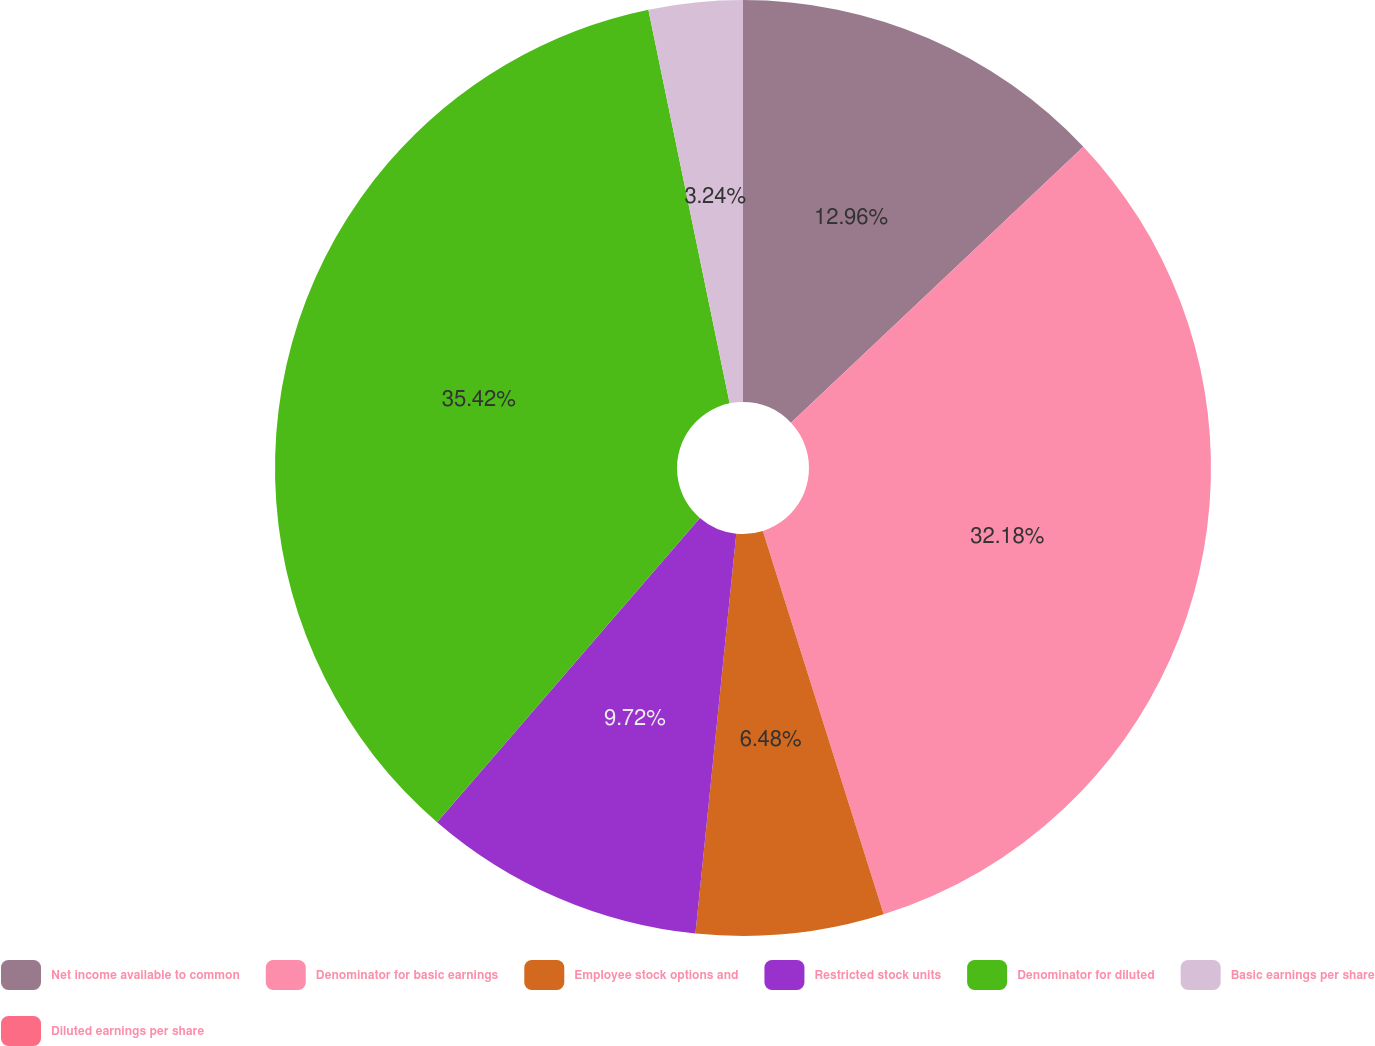<chart> <loc_0><loc_0><loc_500><loc_500><pie_chart><fcel>Net income available to common<fcel>Denominator for basic earnings<fcel>Employee stock options and<fcel>Restricted stock units<fcel>Denominator for diluted<fcel>Basic earnings per share<fcel>Diluted earnings per share<nl><fcel>12.96%<fcel>32.18%<fcel>6.48%<fcel>9.72%<fcel>35.42%<fcel>3.24%<fcel>0.0%<nl></chart> 